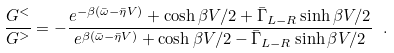<formula> <loc_0><loc_0><loc_500><loc_500>\frac { G ^ { < } } { G ^ { > } } = - \frac { e ^ { - \beta ( \bar { \omega } - \bar { \eta } V ) } + \cosh \beta V / 2 + \bar { \Gamma } _ { L - R } \sinh \beta V / 2 } { e ^ { \beta ( \bar { \omega } - \bar { \eta } V ) } + \cosh \beta V / 2 - \bar { \Gamma } _ { L - R } \sinh \beta V / 2 } \ .</formula> 